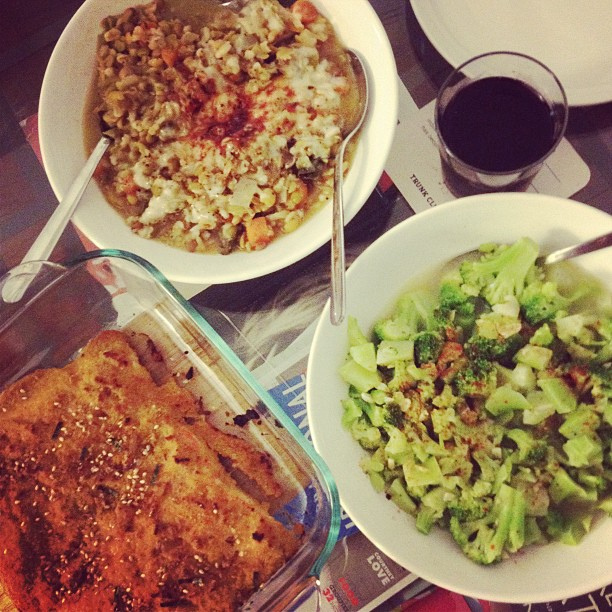Please transcribe the text information in this image. TRUNK CU AL LOVE LOVE LOVE 32 